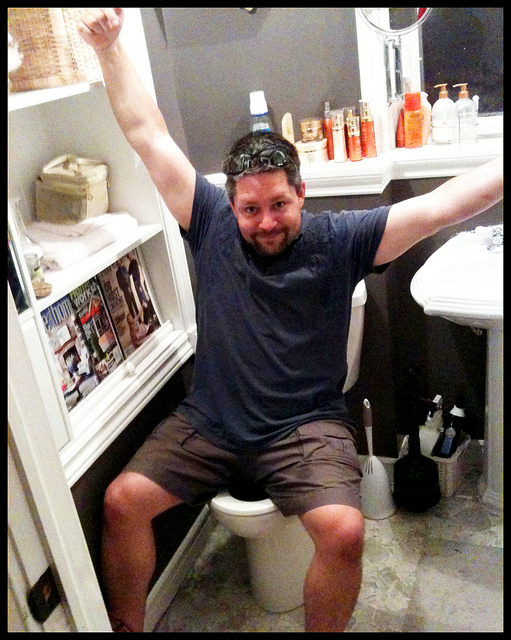<image>What is on this persons head? I don't know exactly what is on this person's head. It can be glasses, swim goggles, or sunglasses. What is on this persons head? I don't know what is on this person's head. It could be glasses, swim goggles, sunglasses, or just their hair. 